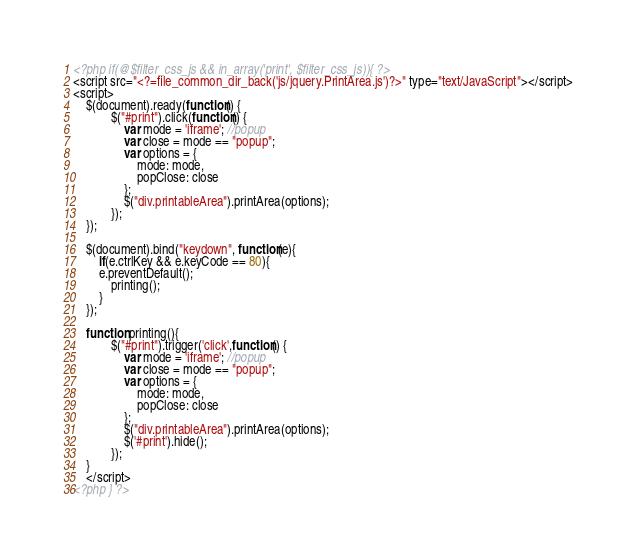<code> <loc_0><loc_0><loc_500><loc_500><_HTML_><?php if(@$filter_css_js && in_array('print', $filter_css_js)){ ?>
<script src="<?=file_common_dir_back('js/jquery.PrintArea.js')?>" type="text/JavaScript"></script>
<script>
    $(document).ready(function() {
            $("#print").click(function() {
                var mode = 'iframe'; //popup
                var close = mode == "popup";
                var options = {
                    mode: mode,
                    popClose: close
                };
                $("div.printableArea").printArea(options);
            });
    });

    $(document).bind("keydown", function(e){
        if(e.ctrlKey && e.keyCode == 80){
        e.preventDefault(); 
            printing();
        }
    });
    
    function printing(){ 
            $("#print").trigger('click',function() {
                var mode = 'iframe'; //popup
                var close = mode == "popup";
                var options = {
                    mode: mode,
                    popClose: close
                };
                $("div.printableArea").printArea(options);
                $('#print').hide();
            });
    }
    </script>
<?php } ?></code> 